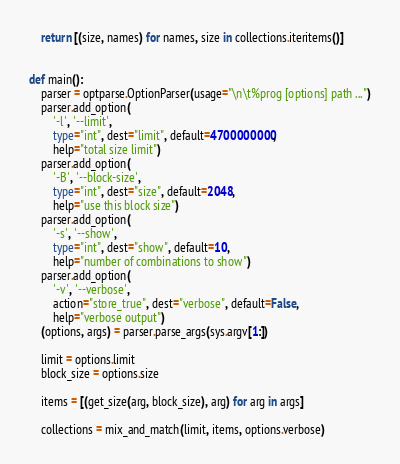<code> <loc_0><loc_0><loc_500><loc_500><_Python_>
    return [(size, names) for names, size in collections.iteritems()]


def main():
    parser = optparse.OptionParser(usage="\n\t%prog [options] path ...")
    parser.add_option(
        '-l', '--limit', 
        type="int", dest="limit", default=4700000000, 
        help="total size limit")
    parser.add_option(
        '-B', '--block-size', 
        type="int", dest="size", default=2048, 
        help="use this block size")
    parser.add_option(
        '-s', '--show', 
        type="int", dest="show", default=10, 
        help="number of combinations to show")
    parser.add_option(
        '-v', '--verbose', 
        action="store_true", dest="verbose", default=False, 
        help="verbose output")
    (options, args) = parser.parse_args(sys.argv[1:])

    limit = options.limit
    block_size = options.size
    
    items = [(get_size(arg, block_size), arg) for arg in args]
    
    collections = mix_and_match(limit, items, options.verbose)</code> 